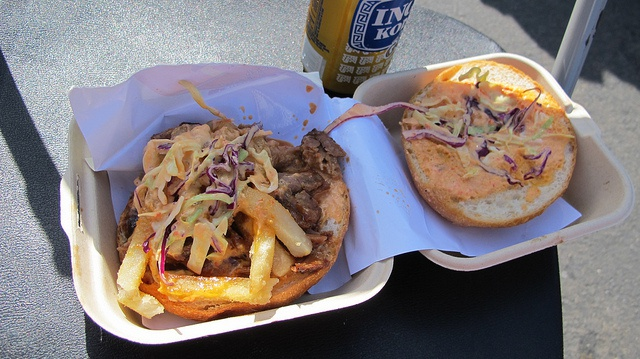Describe the objects in this image and their specific colors. I can see bowl in beige, darkgray, tan, and white tones, bowl in beige, darkgray, gray, tan, and lightblue tones, and bottle in beige, olive, black, darkgray, and gray tones in this image. 